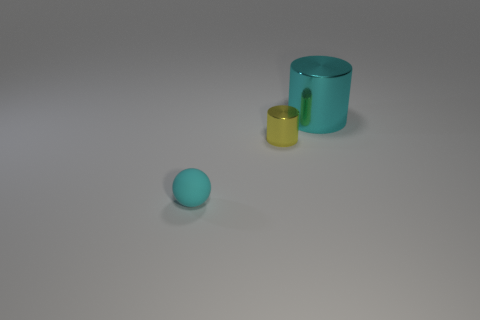The ball that is the same color as the large metallic object is what size?
Provide a succinct answer. Small. What is the material of the big cylinder that is the same color as the ball?
Make the answer very short. Metal. There is a cyan sphere that is the same size as the yellow thing; what material is it?
Offer a very short reply. Rubber. There is a tiny matte sphere that is to the left of the big cylinder; does it have the same color as the big shiny thing?
Offer a terse response. Yes. Does the large cyan cylinder have the same material as the yellow thing?
Your answer should be very brief. Yes. There is a cylinder that is to the right of the tiny object right of the tiny cyan ball; how big is it?
Offer a terse response. Large. Does the large metal object have the same color as the sphere?
Offer a very short reply. Yes. Is there a big cylinder of the same color as the small rubber sphere?
Keep it short and to the point. Yes. There is a cyan object to the right of the cyan object in front of the tiny object that is on the right side of the small rubber object; what size is it?
Make the answer very short. Large. What is the shape of the object that is behind the yellow metal cylinder?
Give a very brief answer. Cylinder. 